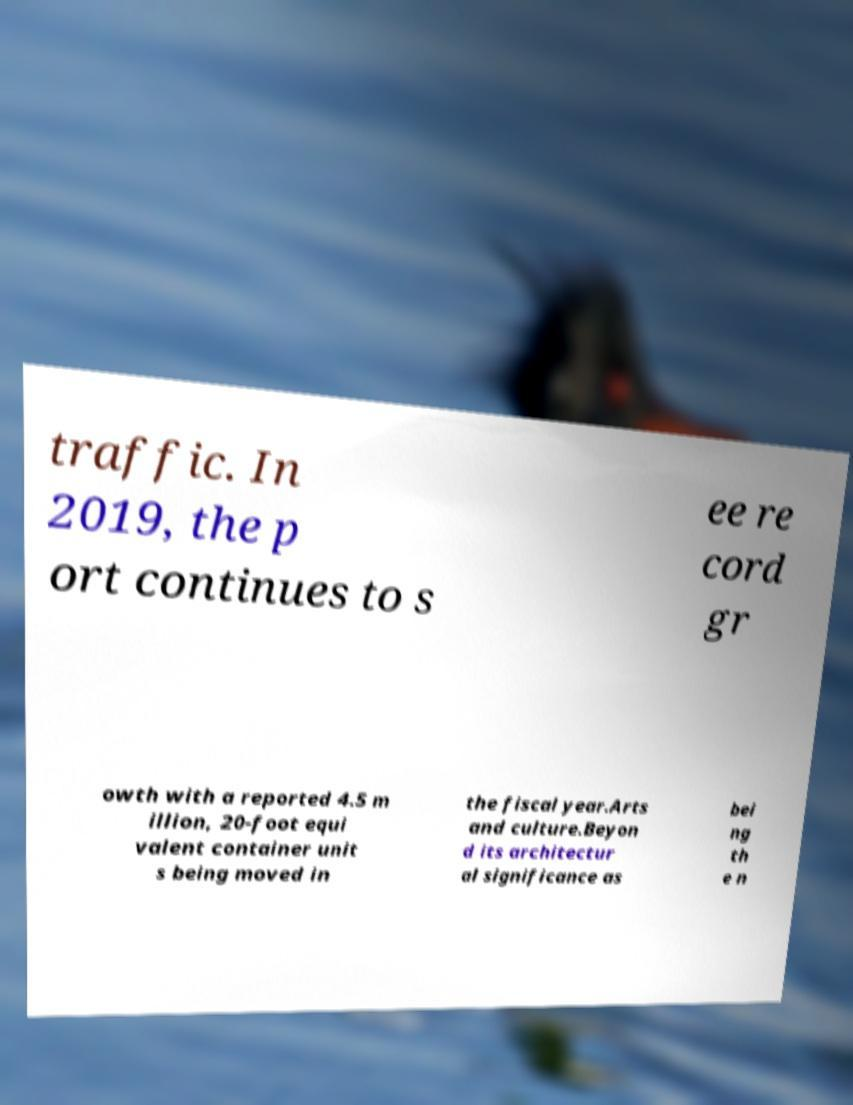There's text embedded in this image that I need extracted. Can you transcribe it verbatim? traffic. In 2019, the p ort continues to s ee re cord gr owth with a reported 4.5 m illion, 20-foot equi valent container unit s being moved in the fiscal year.Arts and culture.Beyon d its architectur al significance as bei ng th e n 